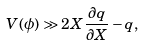Convert formula to latex. <formula><loc_0><loc_0><loc_500><loc_500>V ( \phi ) \gg 2 X \frac { \partial q } { \partial X } - q ,</formula> 